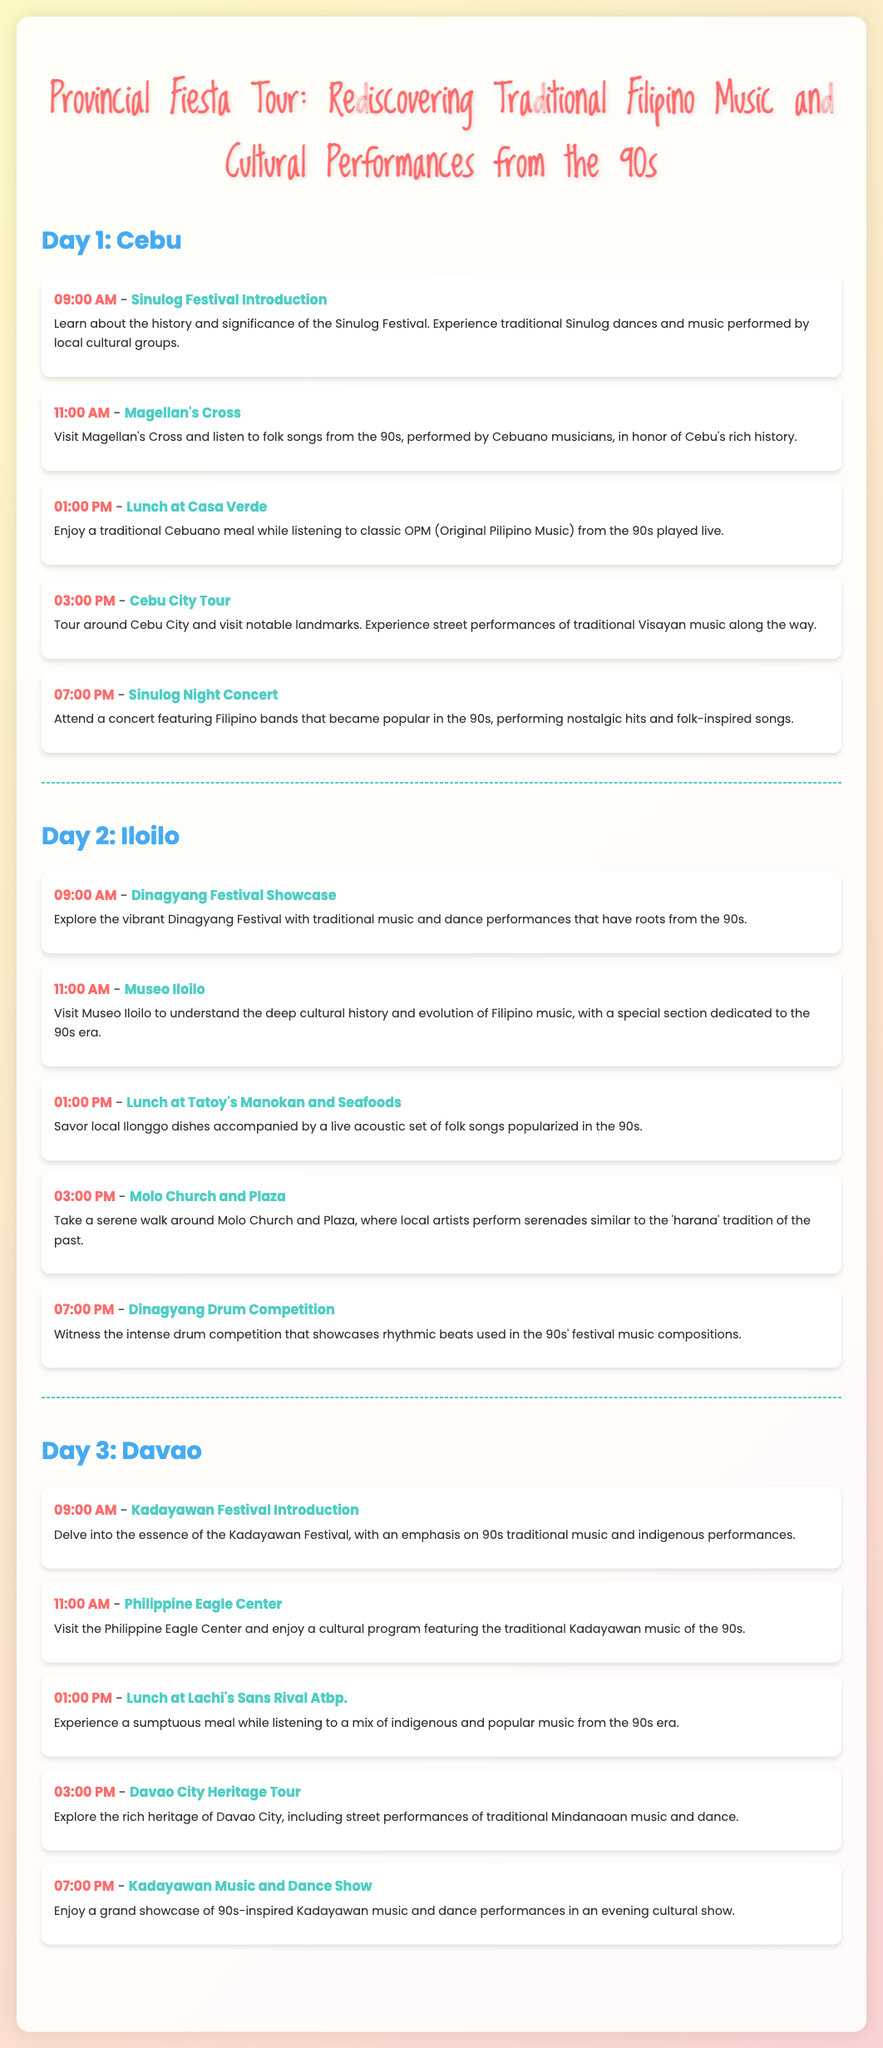What is the title of the itinerary? The title is prominently displayed at the top of the document, referring to the overall theme of the tour.
Answer: Provincial Fiesta Tour: Rediscovering Traditional Filipino Music and Cultural Performances from the 90s How many days does the itinerary cover? The document is structured into three distinct sections, each corresponding to a different day.
Answer: 3 Which city has the Sinulog Festival? The first day's activities highlight a specific festival associated with this city.
Answer: Cebu What time does the Dinagyang Festival Showcase begin? The schedule for the second day lists this specific activity and its start time.
Answer: 09:00 AM What type of music is focused on during the Kadayawan Festival Introduction? The document indicates the festival has a particular emphasis on music from a specified decade.
Answer: 90s traditional music Which venue features a live acoustic set during lunch on Day 2? The second day includes a dining venue where live music is performed.
Answer: Tatoy's Manokan and Seafoods What cultural aspect is highlighted during the Molo Church and Plaza visit? The details mention a traditional musical practice that is nostalgic in nature, linking to Filipino heritage.
Answer: Serenades similar to the 'harana' tradition What type of performance occurs at 07:00 PM on Day 3? The evening event on the last day is described as a cultural show, focusing on a specific kind of performance.
Answer: Kadayawan Music and Dance Show Which local dish is highlighted during lunchtime in Davao? A specific dining venue is mentioned alongside the culinary experience during the meal.
Answer: Lachi's Sans Rival Atbp 